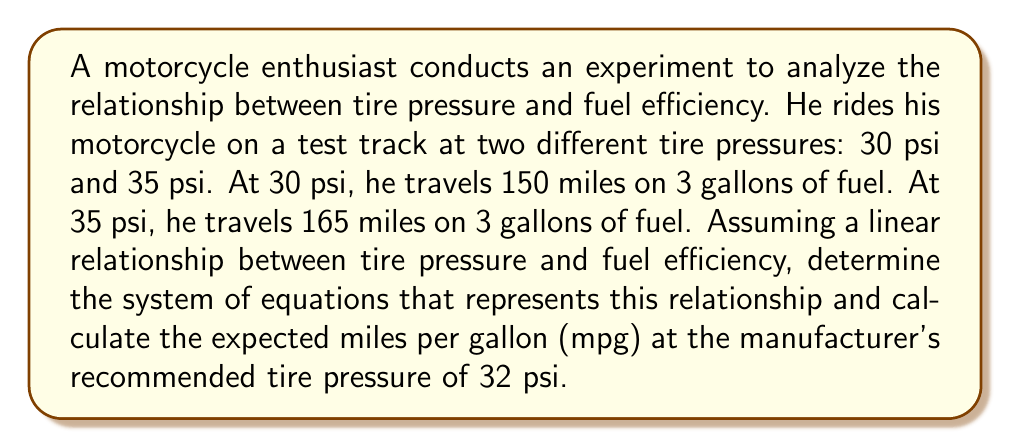What is the answer to this math problem? Let's approach this step-by-step:

1) Let $x$ represent the tire pressure in psi and $y$ represent the fuel efficiency in mpg.

2) We can calculate the mpg for each test:
   At 30 psi: $150 \text{ miles} / 3 \text{ gallons} = 50 \text{ mpg}$
   At 35 psi: $165 \text{ miles} / 3 \text{ gallons} = 55 \text{ mpg}$

3) Now we have two points: (30, 50) and (35, 55)

4) We can form a system of equations using the point-slope form of a line:
   $$y - y_1 = m(x - x_1)$$
   where $m$ is the slope.

5) Calculate the slope:
   $$m = \frac{y_2 - y_1}{x_2 - x_1} = \frac{55 - 50}{35 - 30} = \frac{5}{5} = 1$$

6) Now we can form our system of equations:
   $$y - 50 = 1(x - 30)$$
   $$y = x - 30 + 50$$
   $$y = x + 20$$

7) To find the mpg at 32 psi, we simply substitute $x = 32$ into our equation:
   $$y = 32 + 20 = 52$$

Therefore, at 32 psi, we expect the fuel efficiency to be 52 mpg.
Answer: $y = x + 20$; 52 mpg 